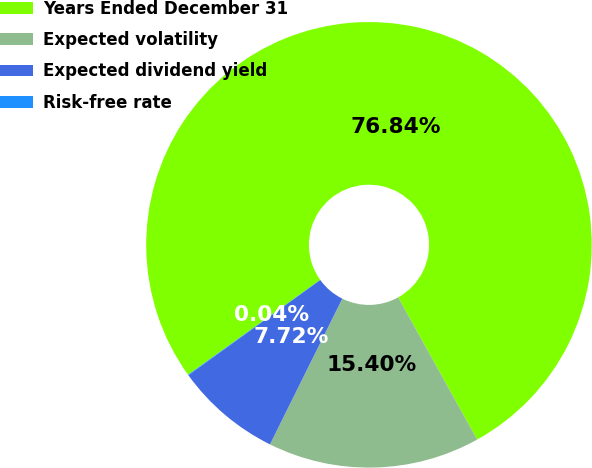Convert chart. <chart><loc_0><loc_0><loc_500><loc_500><pie_chart><fcel>Years Ended December 31<fcel>Expected volatility<fcel>Expected dividend yield<fcel>Risk-free rate<nl><fcel>76.84%<fcel>15.4%<fcel>7.72%<fcel>0.04%<nl></chart> 